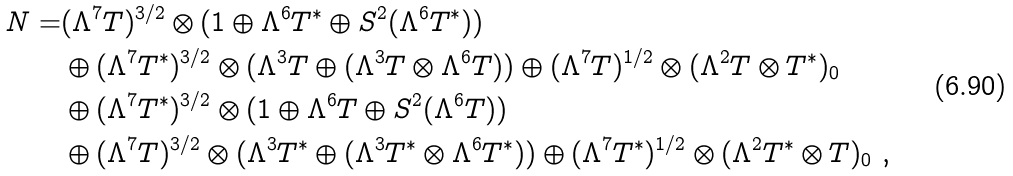Convert formula to latex. <formula><loc_0><loc_0><loc_500><loc_500>N = & ( \Lambda ^ { 7 } T ) ^ { 3 / 2 } \otimes ( 1 \oplus \Lambda ^ { 6 } T ^ { * } \oplus S ^ { 2 } ( \Lambda ^ { 6 } T ^ { * } ) ) \\ & \oplus ( \Lambda ^ { 7 } T ^ { * } ) ^ { 3 / 2 } \otimes ( \Lambda ^ { 3 } T \oplus ( \Lambda ^ { 3 } T \otimes \Lambda ^ { 6 } T ) ) \oplus ( \Lambda ^ { 7 } T ) ^ { 1 / 2 } \otimes ( \Lambda ^ { 2 } T \otimes T ^ { * } ) _ { 0 } \\ & \oplus ( \Lambda ^ { 7 } T ^ { * } ) ^ { 3 / 2 } \otimes ( 1 \oplus \Lambda ^ { 6 } T \oplus S ^ { 2 } ( \Lambda ^ { 6 } T ) ) \\ & \oplus ( \Lambda ^ { 7 } T ) ^ { 3 / 2 } \otimes ( \Lambda ^ { 3 } T ^ { * } \oplus ( \Lambda ^ { 3 } T ^ { * } \otimes \Lambda ^ { 6 } T ^ { * } ) ) \oplus ( \Lambda ^ { 7 } T ^ { * } ) ^ { 1 / 2 } \otimes ( \Lambda ^ { 2 } T ^ { * } \otimes T ) _ { 0 } \ ,</formula> 